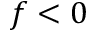<formula> <loc_0><loc_0><loc_500><loc_500>f < 0</formula> 